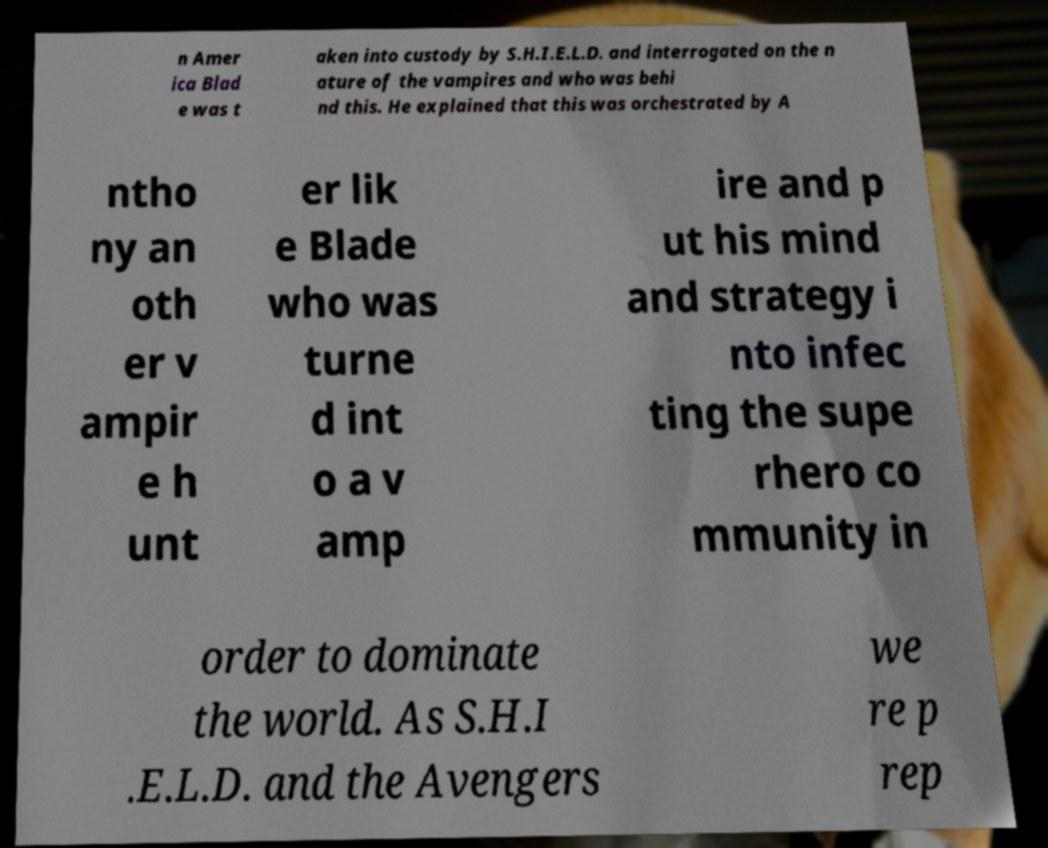Please identify and transcribe the text found in this image. n Amer ica Blad e was t aken into custody by S.H.I.E.L.D. and interrogated on the n ature of the vampires and who was behi nd this. He explained that this was orchestrated by A ntho ny an oth er v ampir e h unt er lik e Blade who was turne d int o a v amp ire and p ut his mind and strategy i nto infec ting the supe rhero co mmunity in order to dominate the world. As S.H.I .E.L.D. and the Avengers we re p rep 